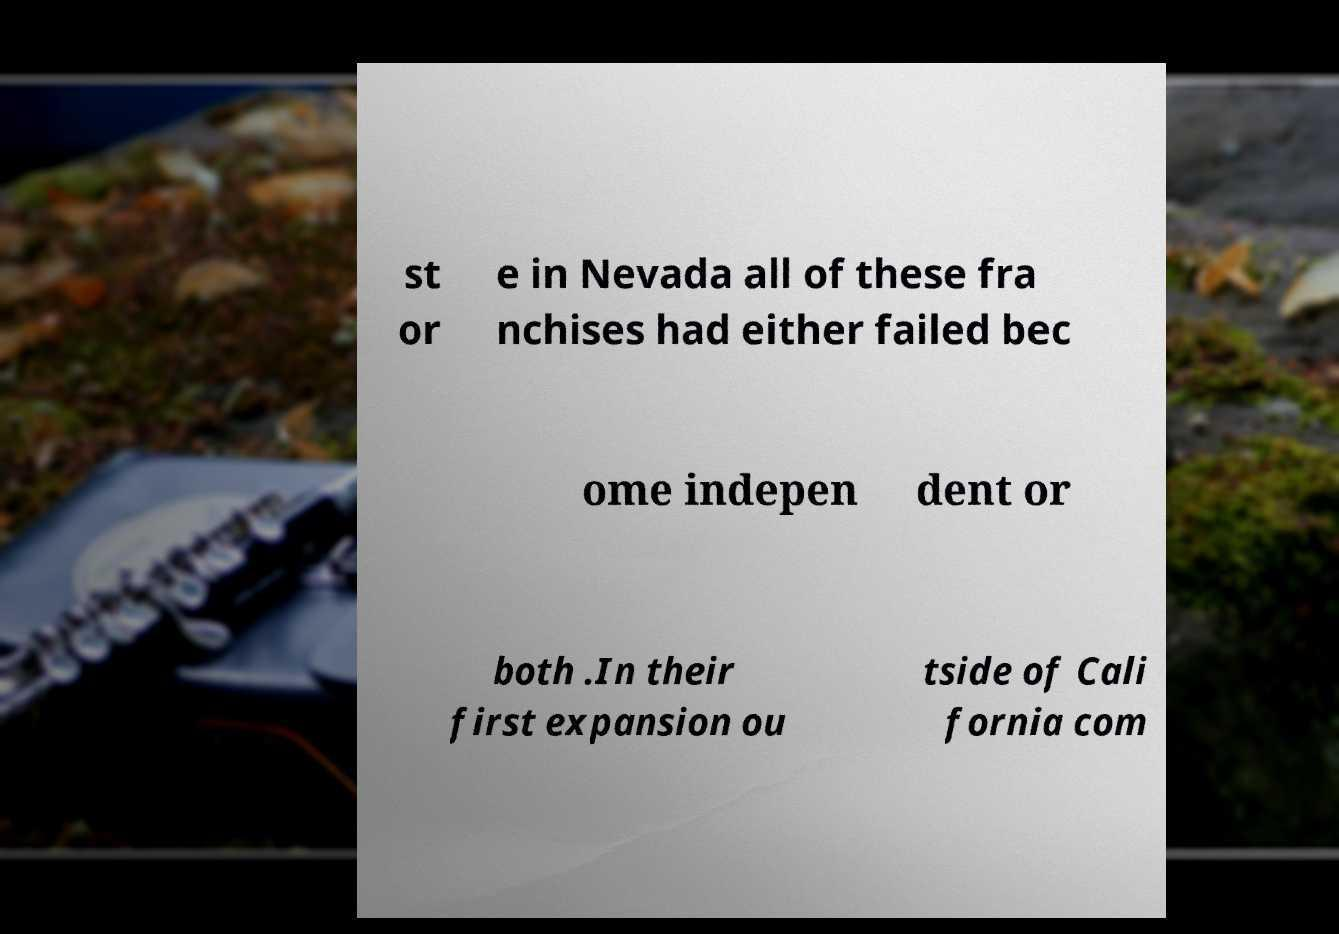Could you assist in decoding the text presented in this image and type it out clearly? st or e in Nevada all of these fra nchises had either failed bec ome indepen dent or both .In their first expansion ou tside of Cali fornia com 